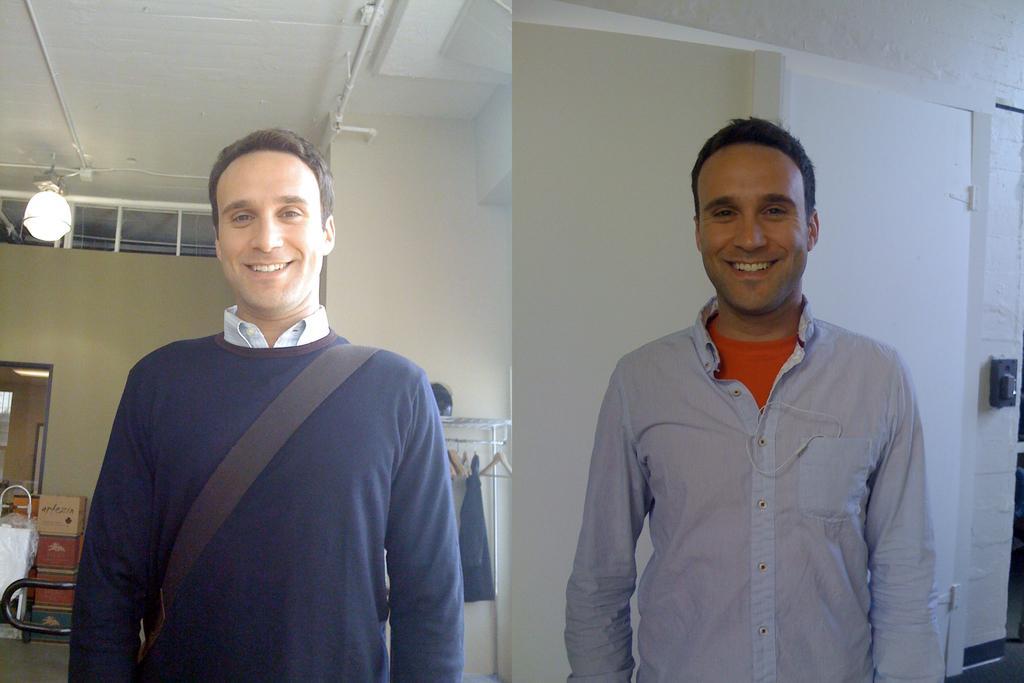Can you describe this image briefly? This image is a collage. In this image there is a man standing and smiling. In the background there are walls, light and we can see cardboard boxes. On the left there is a door. 